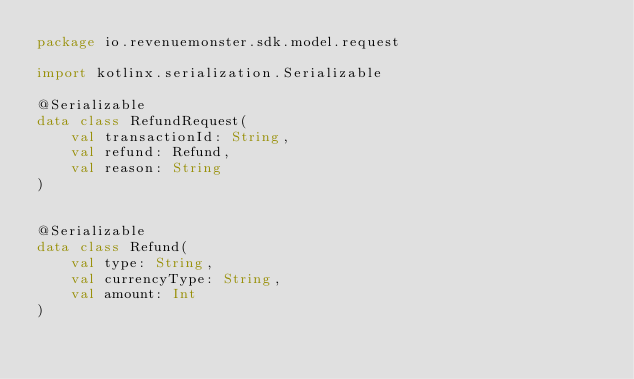<code> <loc_0><loc_0><loc_500><loc_500><_Kotlin_>package io.revenuemonster.sdk.model.request

import kotlinx.serialization.Serializable

@Serializable
data class RefundRequest(
    val transactionId: String,
    val refund: Refund,
    val reason: String
)


@Serializable
data class Refund(
    val type: String,
    val currencyType: String,
    val amount: Int
)</code> 